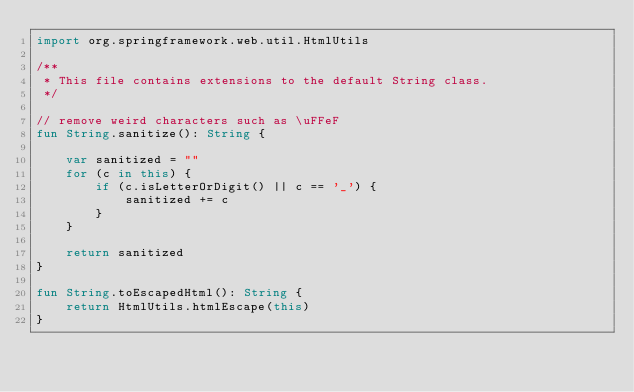<code> <loc_0><loc_0><loc_500><loc_500><_Kotlin_>import org.springframework.web.util.HtmlUtils

/**
 * This file contains extensions to the default String class.
 */

// remove weird characters such as \uFFeF
fun String.sanitize(): String {

    var sanitized = ""
    for (c in this) {
        if (c.isLetterOrDigit() || c == '_') {
            sanitized += c
        }
    }

    return sanitized
}

fun String.toEscapedHtml(): String {
    return HtmlUtils.htmlEscape(this)
}
    
    
</code> 